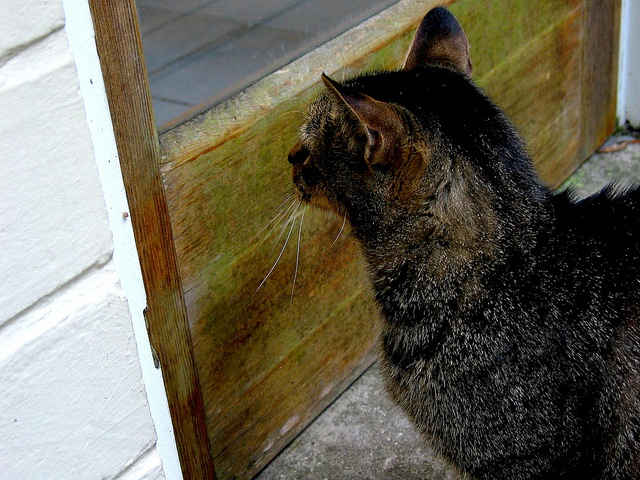Describe the objects in this image and their specific colors. I can see a cat in white, black, gray, olive, and maroon tones in this image. 